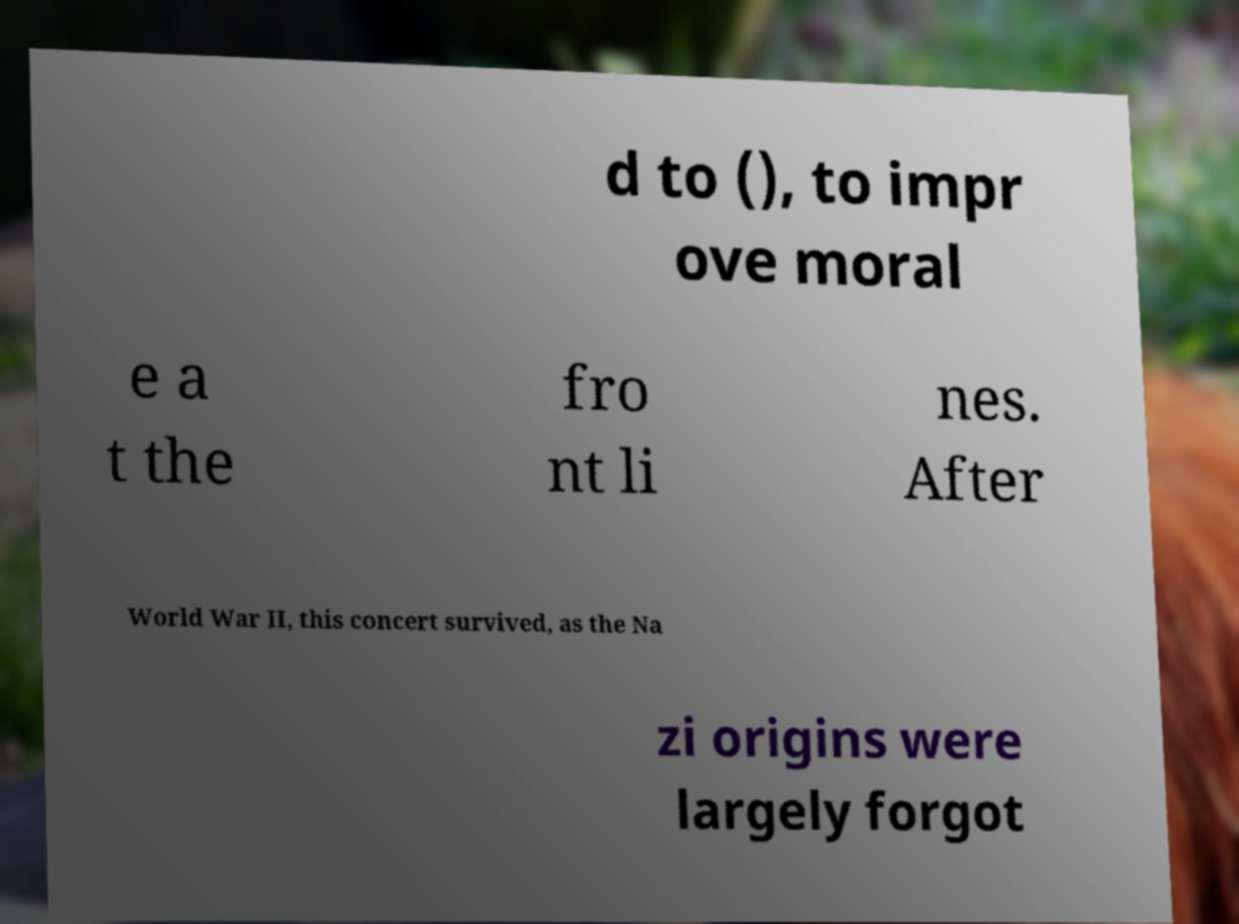There's text embedded in this image that I need extracted. Can you transcribe it verbatim? d to (), to impr ove moral e a t the fro nt li nes. After World War II, this concert survived, as the Na zi origins were largely forgot 